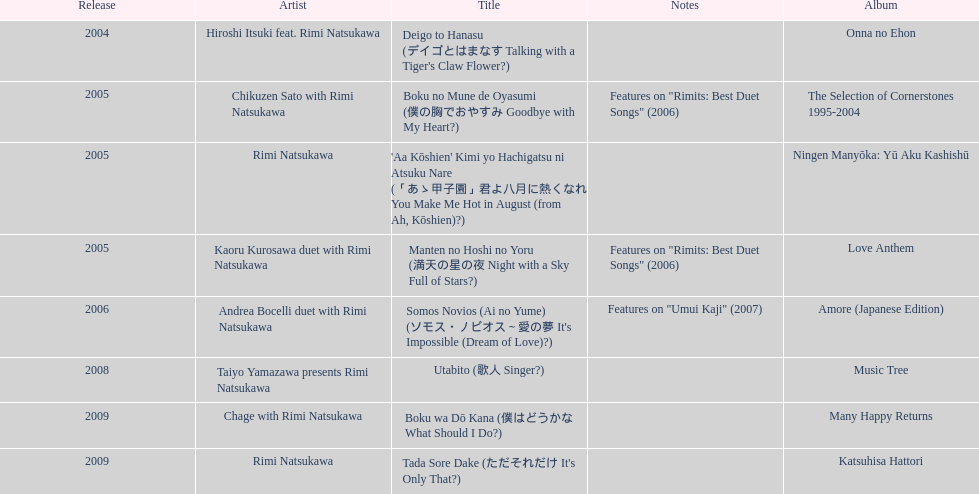Between onna no ehon and music tree, which one was not released in 2004? Music Tree. 